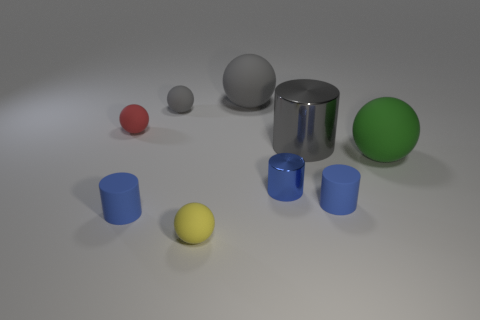Subtract all blue cylinders. How many were subtracted if there are1blue cylinders left? 2 Subtract all gray matte spheres. How many spheres are left? 3 Subtract all balls. How many objects are left? 4 Subtract 5 spheres. How many spheres are left? 0 Add 2 tiny blue metal cylinders. How many tiny blue metal cylinders are left? 3 Add 5 blue matte cylinders. How many blue matte cylinders exist? 7 Add 1 tiny metal cylinders. How many objects exist? 10 Subtract all gray spheres. How many spheres are left? 3 Subtract 0 purple cylinders. How many objects are left? 9 Subtract all green spheres. Subtract all purple cubes. How many spheres are left? 4 